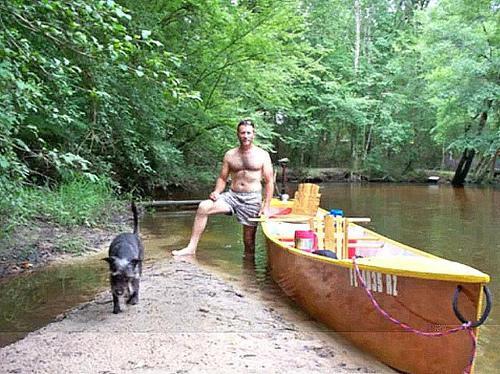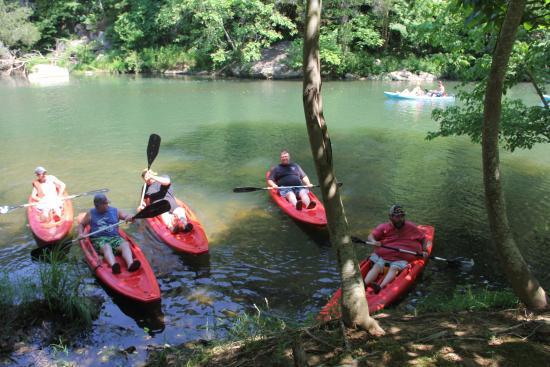The first image is the image on the left, the second image is the image on the right. Evaluate the accuracy of this statement regarding the images: "An image shows a woman in a life vest and sunglasses holding a raised oar while sitting in a canoe on the water.". Is it true? Answer yes or no. No. 